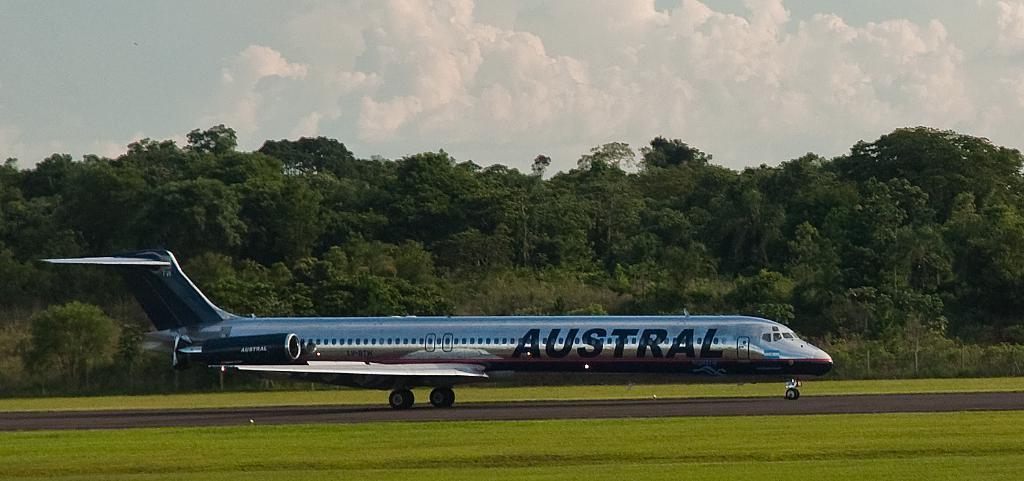What is the airline of the plane?
Keep it short and to the point. Austral. What is the first letter of the airline?
Keep it short and to the point. A. 